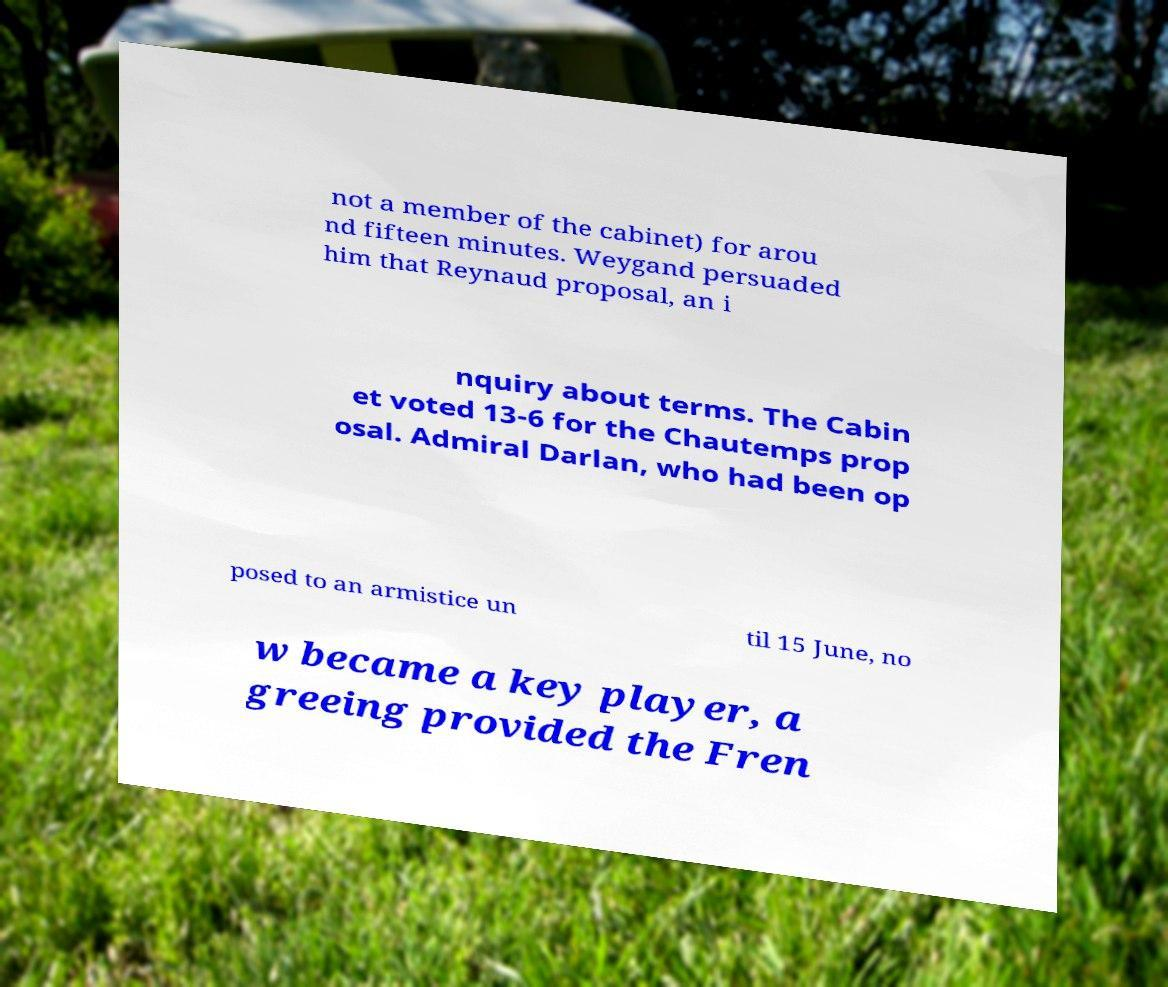Can you read and provide the text displayed in the image?This photo seems to have some interesting text. Can you extract and type it out for me? not a member of the cabinet) for arou nd fifteen minutes. Weygand persuaded him that Reynaud proposal, an i nquiry about terms. The Cabin et voted 13-6 for the Chautemps prop osal. Admiral Darlan, who had been op posed to an armistice un til 15 June, no w became a key player, a greeing provided the Fren 